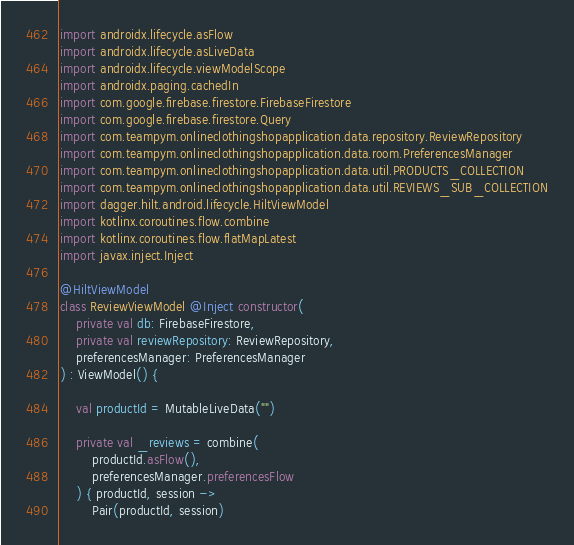Convert code to text. <code><loc_0><loc_0><loc_500><loc_500><_Kotlin_>import androidx.lifecycle.asFlow
import androidx.lifecycle.asLiveData
import androidx.lifecycle.viewModelScope
import androidx.paging.cachedIn
import com.google.firebase.firestore.FirebaseFirestore
import com.google.firebase.firestore.Query
import com.teampym.onlineclothingshopapplication.data.repository.ReviewRepository
import com.teampym.onlineclothingshopapplication.data.room.PreferencesManager
import com.teampym.onlineclothingshopapplication.data.util.PRODUCTS_COLLECTION
import com.teampym.onlineclothingshopapplication.data.util.REVIEWS_SUB_COLLECTION
import dagger.hilt.android.lifecycle.HiltViewModel
import kotlinx.coroutines.flow.combine
import kotlinx.coroutines.flow.flatMapLatest
import javax.inject.Inject

@HiltViewModel
class ReviewViewModel @Inject constructor(
    private val db: FirebaseFirestore,
    private val reviewRepository: ReviewRepository,
    preferencesManager: PreferencesManager
) : ViewModel() {

    val productId = MutableLiveData("")

    private val _reviews = combine(
        productId.asFlow(),
        preferencesManager.preferencesFlow
    ) { productId, session ->
        Pair(productId, session)</code> 